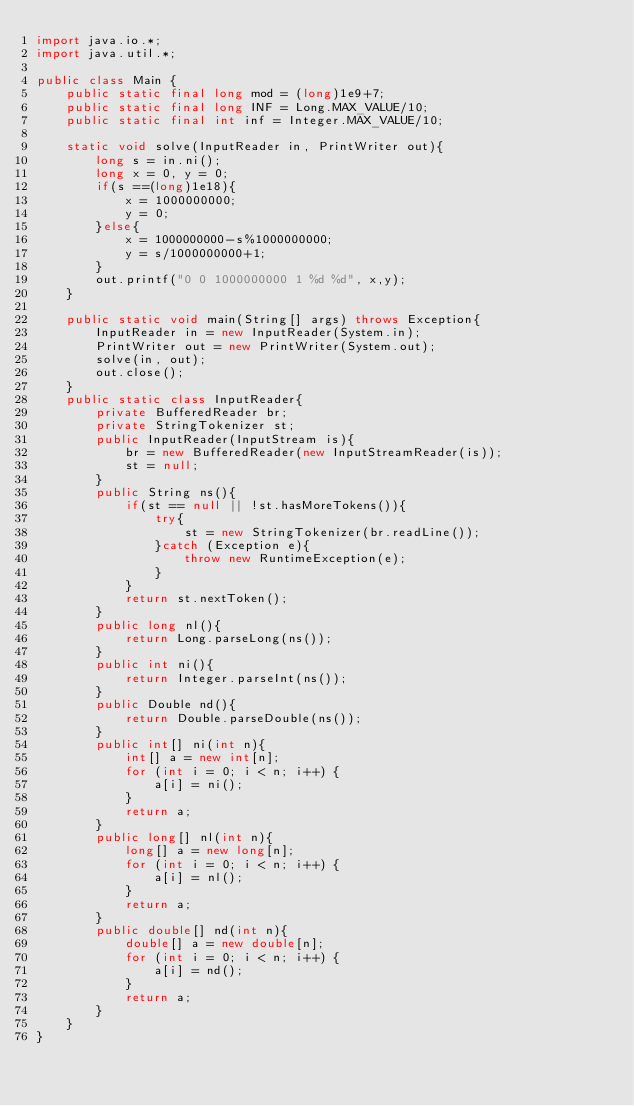<code> <loc_0><loc_0><loc_500><loc_500><_Java_>import java.io.*;
import java.util.*;

public class Main {
    public static final long mod = (long)1e9+7;
    public static final long INF = Long.MAX_VALUE/10;
    public static final int inf = Integer.MAX_VALUE/10;

    static void solve(InputReader in, PrintWriter out){
        long s = in.ni();
        long x = 0, y = 0;
        if(s ==(long)1e18){
            x = 1000000000;
            y = 0;
        }else{
            x = 1000000000-s%1000000000;
            y = s/1000000000+1;
        }
        out.printf("0 0 1000000000 1 %d %d", x,y);
    }

    public static void main(String[] args) throws Exception{
        InputReader in = new InputReader(System.in);
        PrintWriter out = new PrintWriter(System.out);
        solve(in, out);
        out.close();
    }
    public static class InputReader{
        private BufferedReader br;
        private StringTokenizer st;
        public InputReader(InputStream is){
            br = new BufferedReader(new InputStreamReader(is));
            st = null;
        }
        public String ns(){
            if(st == null || !st.hasMoreTokens()){
                try{
                    st = new StringTokenizer(br.readLine());
                }catch (Exception e){
                    throw new RuntimeException(e);
                }
            }
            return st.nextToken();
        }
        public long nl(){
            return Long.parseLong(ns());
        }
        public int ni(){
            return Integer.parseInt(ns());
        }
        public Double nd(){
            return Double.parseDouble(ns());
        }
        public int[] ni(int n){
            int[] a = new int[n];
            for (int i = 0; i < n; i++) {
                a[i] = ni();
            }
            return a;
        }
        public long[] nl(int n){
            long[] a = new long[n];
            for (int i = 0; i < n; i++) {
                a[i] = nl();
            }
            return a;
        }
        public double[] nd(int n){
            double[] a = new double[n];
            for (int i = 0; i < n; i++) {
                a[i] = nd();
            }
            return a;
        }
    }
}</code> 